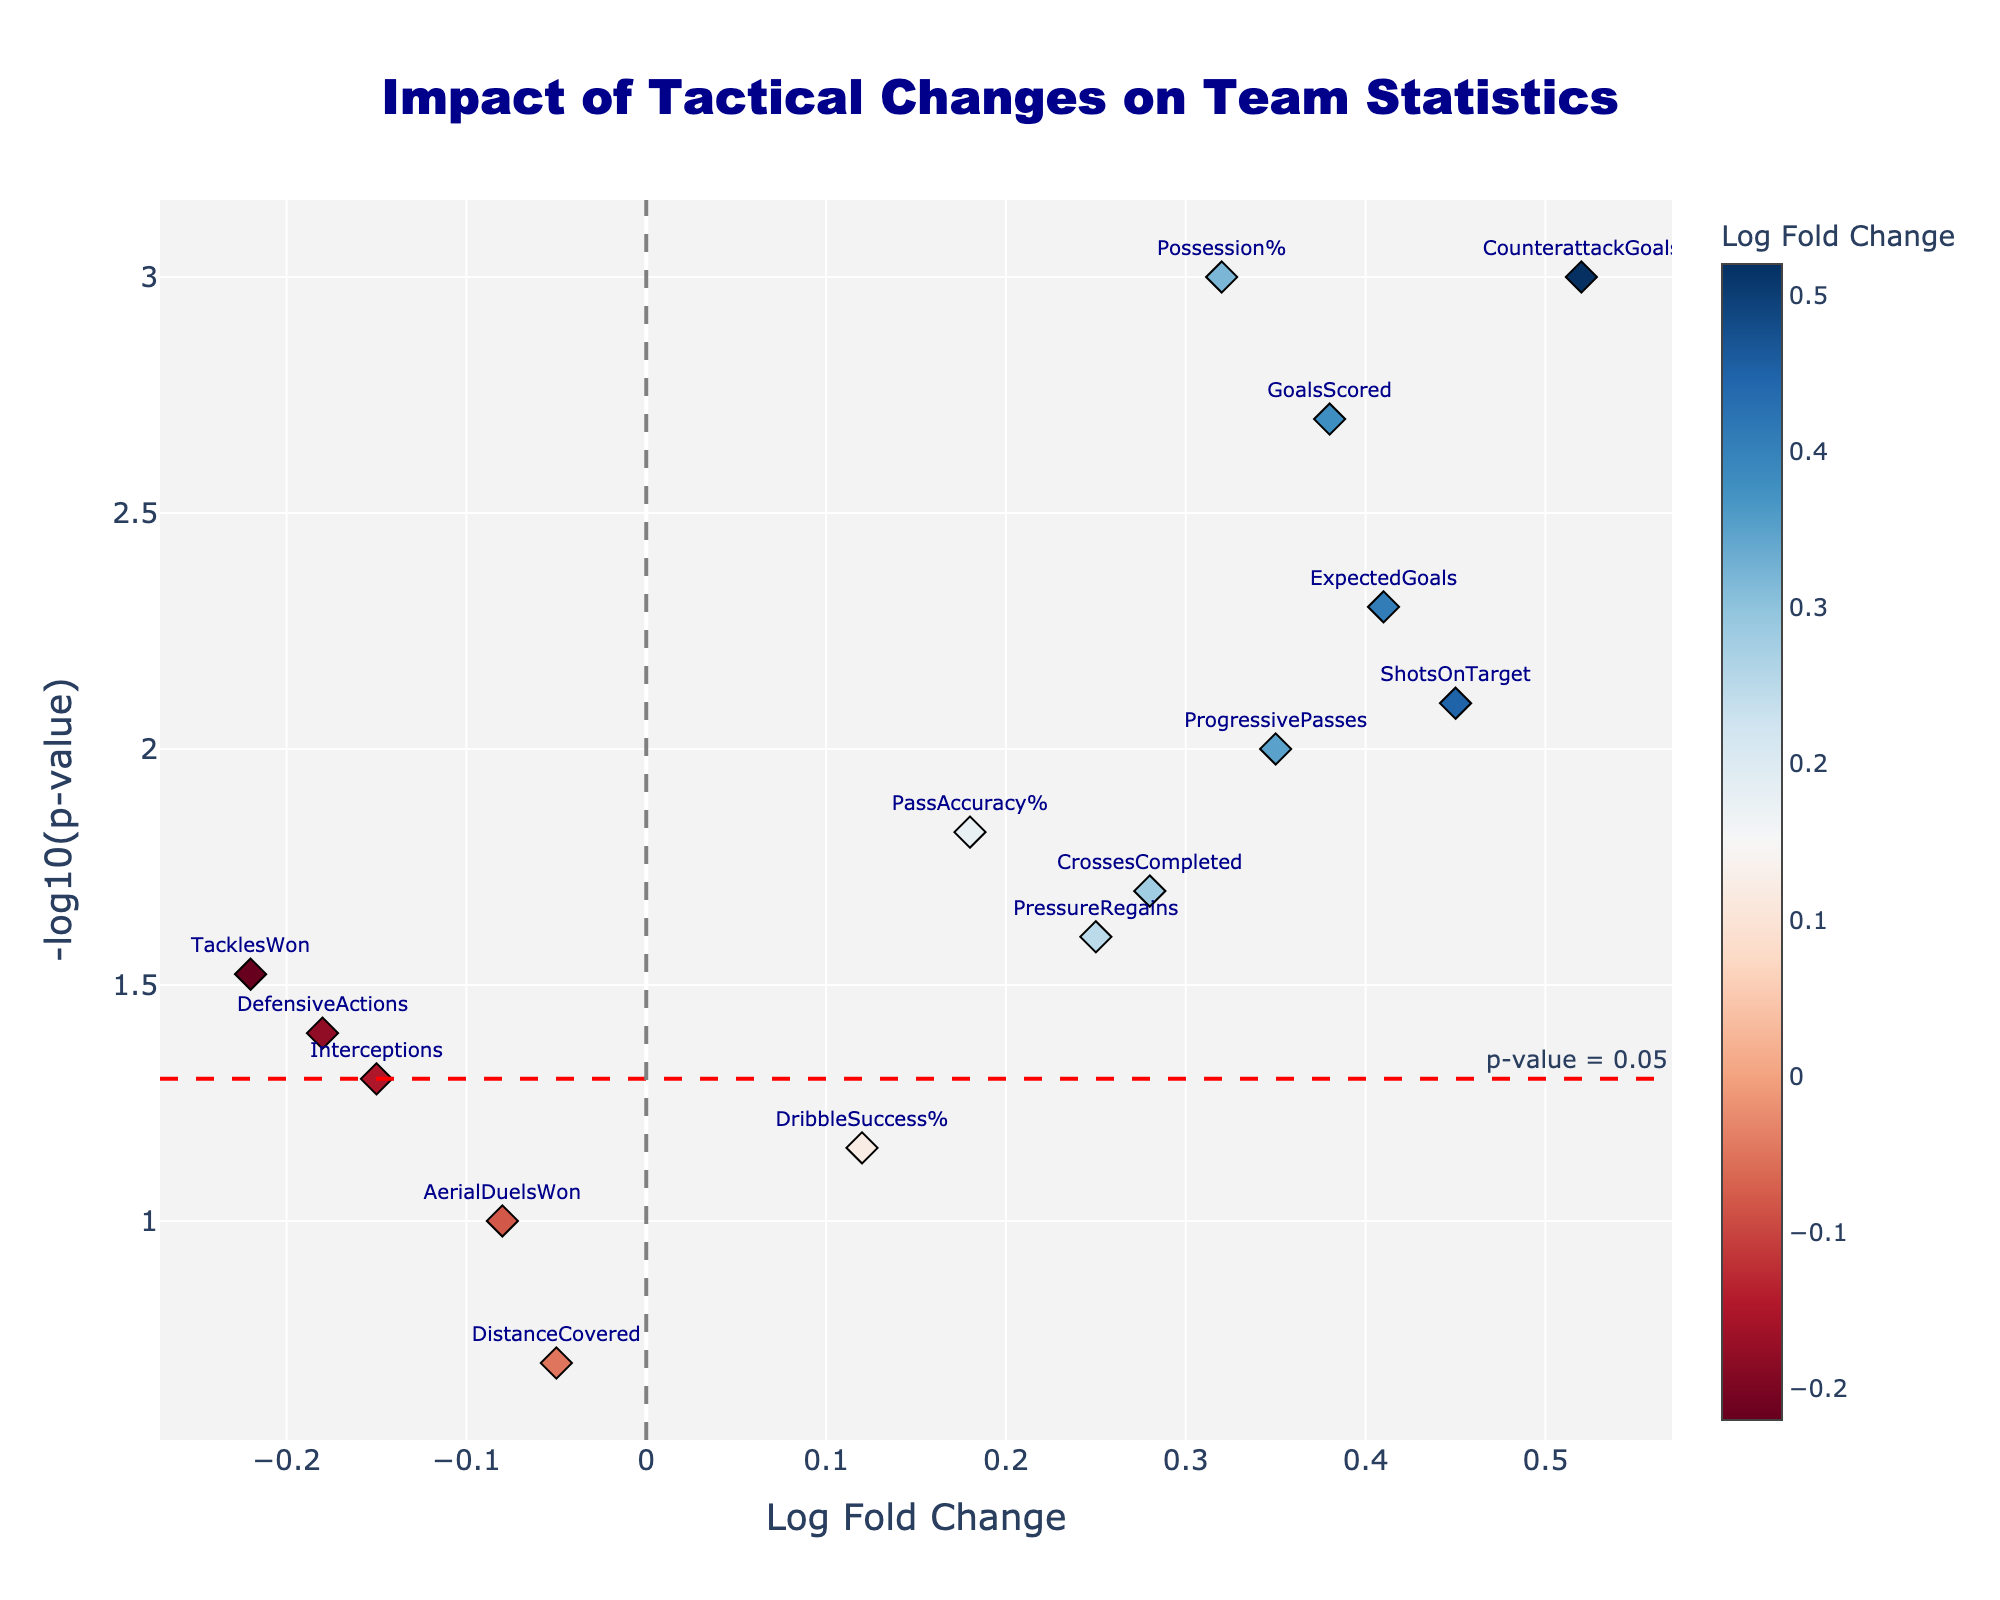What is the title of the plot? The title is the main text displayed at the top of the plot. It is set to help viewers immediately understand the subject of the figure. In this plot, the title is clearly written and prominently positioned.
Answer: Impact of Tactical Changes on Team Statistics How many data points are there in the plot? By counting the number of markers or points in the plot, you can determine the number of data points. Each point represents a different statistic.
Answer: 14 Which statistic experienced the highest increase in log fold change? To find the highest increase, look for the data point with the maximum positive value along the x-axis. This will be the point furthest to the right.
Answer: CounterattackGoals What does the red dashed horizontal line represent? The red dashed line is a threshold line that is usually annotated to indicate significant p-values, helping to determine statistical significance. According to the plot annotation, it represents a p-value threshold.
Answer: p-value = 0.05 Which statistic has the lowest (most negative) log fold change? Look for the data point with the most negative value along the x-axis as the statistic with the lowest change. It will be the point furthest to the left.
Answer: TacklesWon Which statistic has a p-value closest to the threshold line? Examine the vertical positions of the points to see which one is closest to the red dashed horizontal line. This line represents a p-value of 0.05, and the y-axis is on a -log10 scale.
Answer: Interceptions How many statistics are considered statistically significant (p-value < 0.05)? Check how many data points are above the threshold red dashed horizontal line. Each point above this line has a p-value less than 0.05.
Answer: 10 Between Possession% and TacklesWon, which statistic has a lower p-value? Compare the y-values of the points for Possession% and TacklesWon. The higher the point on the y-axis, the lower the p-value.
Answer: Possession% Which two statistics have the closest log fold change values? Examine the x-values of the points to determine which two statistics have the closest values by visual proximity on the x-axis.
Answer: DefensiveActions and TacklesWon What does a positive log fold change signify in terms of team statistics performance? A positive log fold change indicates that the tactical change led to an improvement or increase in the respective statistic compared to the pre-formation shift.
Answer: Improvement in performance 